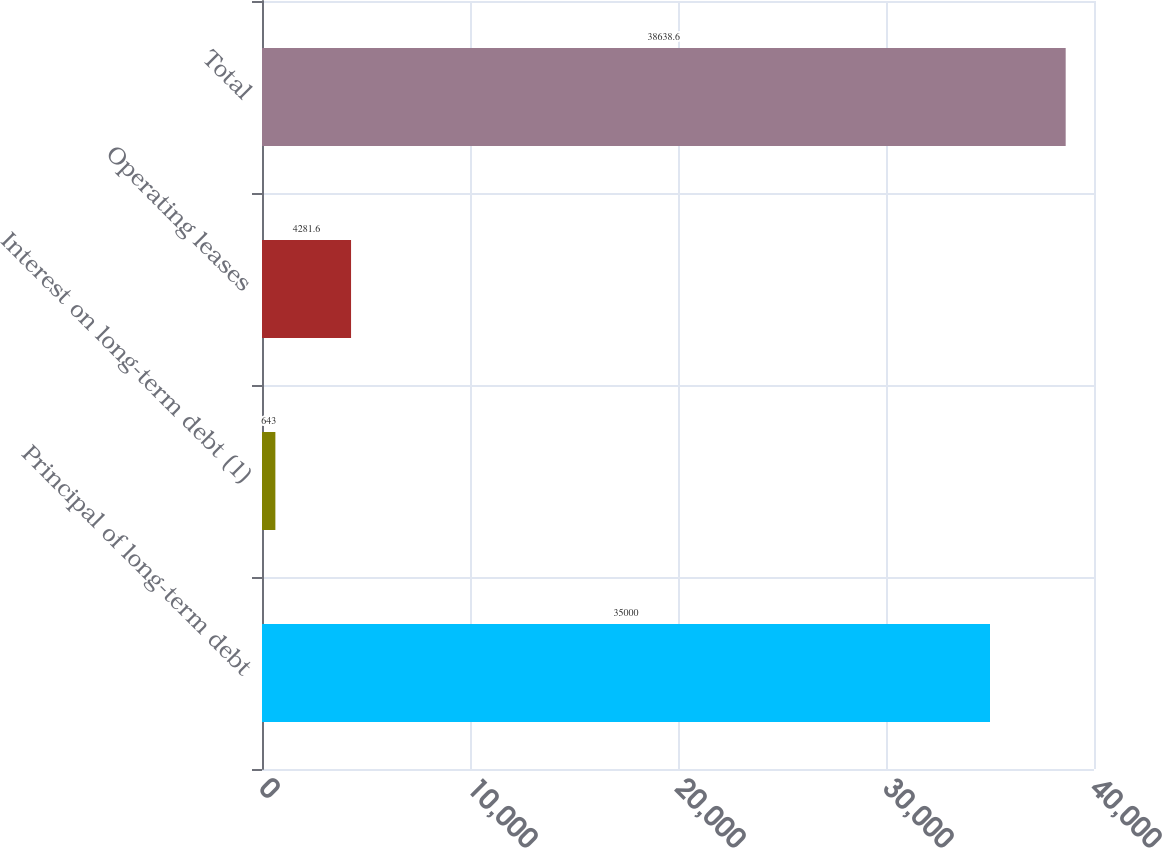<chart> <loc_0><loc_0><loc_500><loc_500><bar_chart><fcel>Principal of long-term debt<fcel>Interest on long-term debt (1)<fcel>Operating leases<fcel>Total<nl><fcel>35000<fcel>643<fcel>4281.6<fcel>38638.6<nl></chart> 